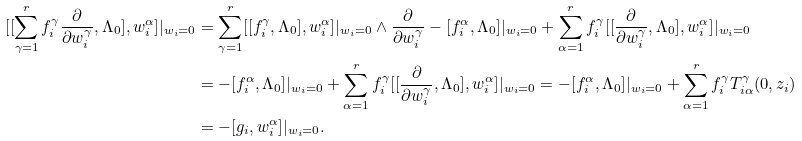<formula> <loc_0><loc_0><loc_500><loc_500>[ [ \sum _ { \gamma = 1 } ^ { r } f _ { i } ^ { \gamma } \frac { \partial } { \partial w _ { i } ^ { \gamma } } , \Lambda _ { 0 } ] , w _ { i } ^ { \alpha } ] | _ { w _ { i } = 0 } & = \sum _ { \gamma = 1 } ^ { r } [ [ f _ { i } ^ { \gamma } , \Lambda _ { 0 } ] , w _ { i } ^ { \alpha } ] | _ { w _ { i } = 0 } \wedge \frac { \partial } { \partial w _ { i } ^ { \gamma } } - [ f _ { i } ^ { \alpha } , \Lambda _ { 0 } ] | _ { w _ { i } = 0 } + \sum _ { \alpha = 1 } ^ { r } f _ { i } ^ { \gamma } [ [ \frac { \partial } { \partial w _ { i } ^ { \gamma } } , \Lambda _ { 0 } ] , w _ { i } ^ { \alpha } ] | _ { w _ { i } = 0 } \\ & = - [ f _ { i } ^ { \alpha } , \Lambda _ { 0 } ] | _ { w _ { i } = 0 } + \sum _ { \alpha = 1 } ^ { r } f _ { i } ^ { \gamma } [ [ \frac { \partial } { \partial w _ { i } ^ { \gamma } } , \Lambda _ { 0 } ] , w _ { i } ^ { \alpha } ] | _ { w _ { i } = 0 } = - [ f _ { i } ^ { \alpha } , \Lambda _ { 0 } ] | _ { w _ { i } = 0 } + \sum _ { \alpha = 1 } ^ { r } f _ { i } ^ { \gamma } T _ { i \alpha } ^ { \gamma } ( 0 , z _ { i } ) \\ & = - [ g _ { i } , w _ { i } ^ { \alpha } ] | _ { w _ { i } = 0 } .</formula> 